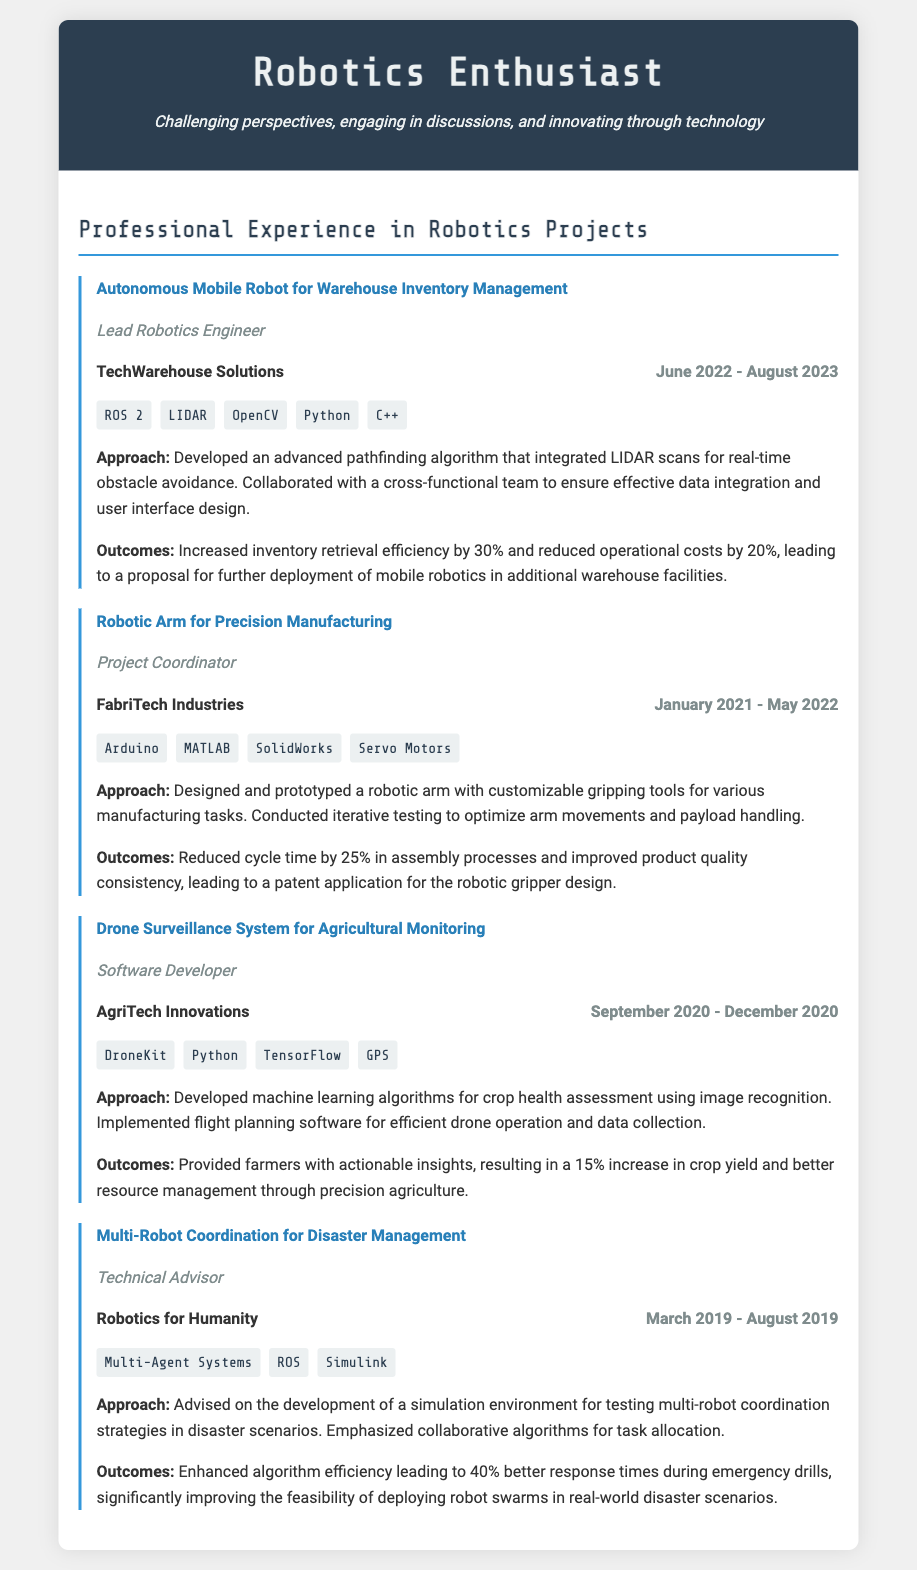What was the role of the person in the Autonomous Mobile Robot project? The role listed in the document for this project is "Lead Robotics Engineer."
Answer: Lead Robotics Engineer Which organization did the Robotic Arm project take place at? The organization mentioned for this project is "FabriTech Industries."
Answer: FabriTech Industries What technology was used in the Drone Surveillance System project? The document mentions several technologies; one of them is "DroneKit."
Answer: DroneKit What was the duration of the Multi-Robot Coordination project? The project duration is specified as "March 2019 - August 2019."
Answer: March 2019 - August 2019 How much did the efficiency increase in inventory retrieval for the warehouse robot? The document states an increase of "30%."
Answer: 30% What approach was used for the Robotic Arm's development? The approach included designing and prototyping a robotic arm.
Answer: Designing and prototyping a robotic arm What was the outcome for farmers using the Drone Surveillance System? The outcome reported was a "15% increase in crop yield."
Answer: 15% increase in crop yield Which project involved the Smart Algorithms for task allocation? This is related to the "Multi-Robot Coordination for Disaster Management" project.
Answer: Multi-Robot Coordination for Disaster Management What engineering method was employed in the Autonomous Mobile Robot project? The method used was an "advanced pathfinding algorithm."
Answer: Advanced pathfinding algorithm 